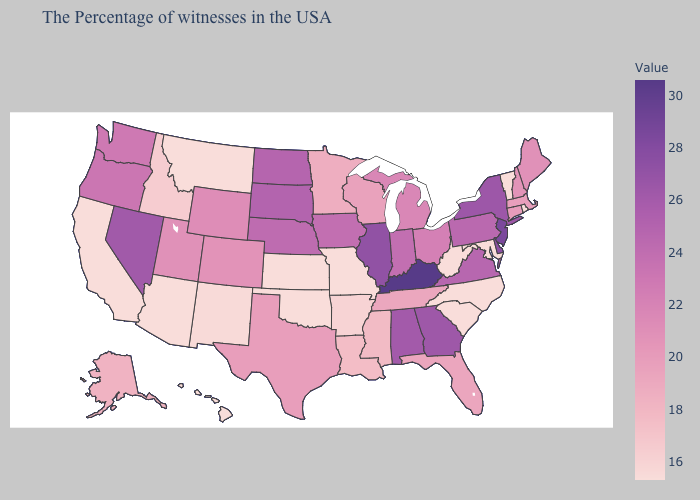Does Missouri have the lowest value in the USA?
Concise answer only. Yes. Does South Dakota have the lowest value in the USA?
Give a very brief answer. No. Which states have the lowest value in the USA?
Concise answer only. Rhode Island, Vermont, Maryland, North Carolina, South Carolina, West Virginia, Missouri, Kansas, Oklahoma, Montana, Arizona, California, Hawaii. Among the states that border Ohio , does West Virginia have the highest value?
Give a very brief answer. No. Is the legend a continuous bar?
Short answer required. Yes. Is the legend a continuous bar?
Answer briefly. Yes. 